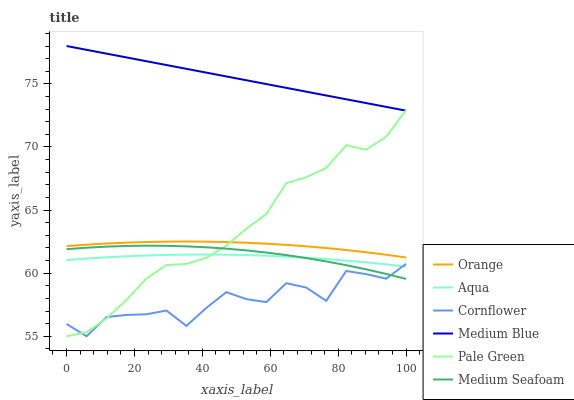Does Cornflower have the minimum area under the curve?
Answer yes or no. Yes. Does Medium Blue have the maximum area under the curve?
Answer yes or no. Yes. Does Aqua have the minimum area under the curve?
Answer yes or no. No. Does Aqua have the maximum area under the curve?
Answer yes or no. No. Is Medium Blue the smoothest?
Answer yes or no. Yes. Is Cornflower the roughest?
Answer yes or no. Yes. Is Aqua the smoothest?
Answer yes or no. No. Is Aqua the roughest?
Answer yes or no. No. Does Cornflower have the lowest value?
Answer yes or no. Yes. Does Aqua have the lowest value?
Answer yes or no. No. Does Medium Blue have the highest value?
Answer yes or no. Yes. Does Aqua have the highest value?
Answer yes or no. No. Is Cornflower less than Orange?
Answer yes or no. Yes. Is Medium Blue greater than Medium Seafoam?
Answer yes or no. Yes. Does Cornflower intersect Medium Seafoam?
Answer yes or no. Yes. Is Cornflower less than Medium Seafoam?
Answer yes or no. No. Is Cornflower greater than Medium Seafoam?
Answer yes or no. No. Does Cornflower intersect Orange?
Answer yes or no. No. 